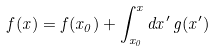Convert formula to latex. <formula><loc_0><loc_0><loc_500><loc_500>f ( x ) = f ( x _ { 0 } ) + \int _ { x _ { 0 } } ^ { x } d x ^ { \prime } \, g ( x ^ { \prime } ) \,</formula> 